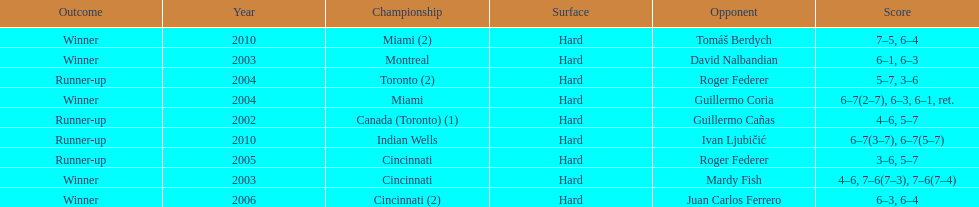How many times was roger federer a runner-up? 2. 